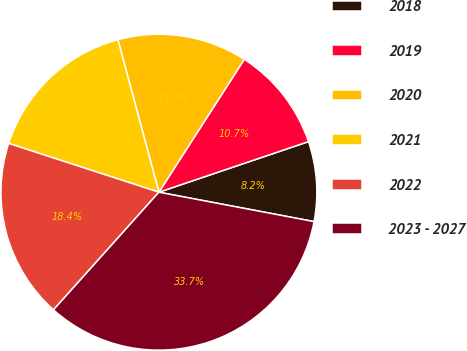Convert chart to OTSL. <chart><loc_0><loc_0><loc_500><loc_500><pie_chart><fcel>2018<fcel>2019<fcel>2020<fcel>2021<fcel>2022<fcel>2023 - 2027<nl><fcel>8.17%<fcel>10.72%<fcel>13.27%<fcel>15.82%<fcel>18.37%<fcel>33.65%<nl></chart> 